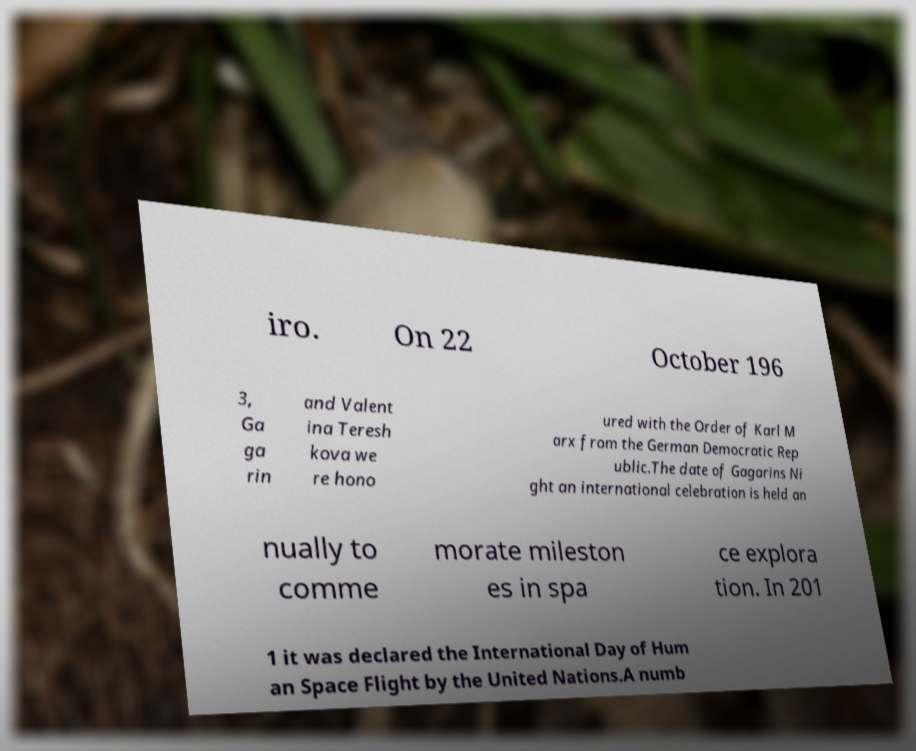What messages or text are displayed in this image? I need them in a readable, typed format. iro. On 22 October 196 3, Ga ga rin and Valent ina Teresh kova we re hono ured with the Order of Karl M arx from the German Democratic Rep ublic.The date of Gagarins Ni ght an international celebration is held an nually to comme morate mileston es in spa ce explora tion. In 201 1 it was declared the International Day of Hum an Space Flight by the United Nations.A numb 